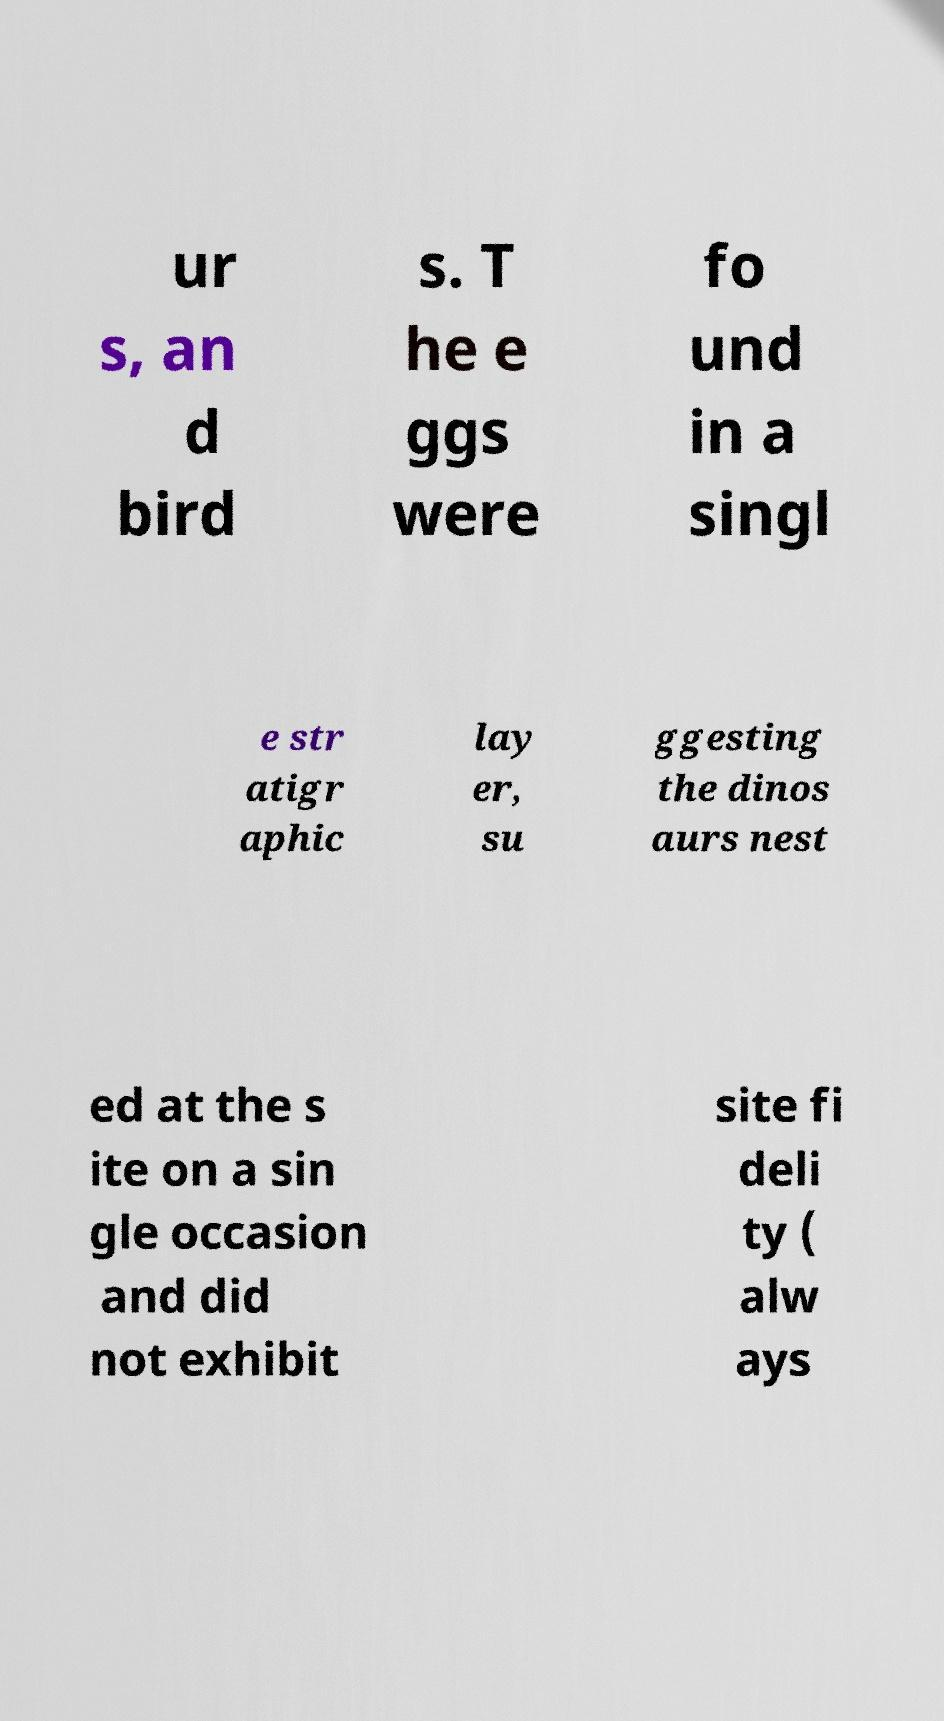Could you extract and type out the text from this image? ur s, an d bird s. T he e ggs were fo und in a singl e str atigr aphic lay er, su ggesting the dinos aurs nest ed at the s ite on a sin gle occasion and did not exhibit site fi deli ty ( alw ays 